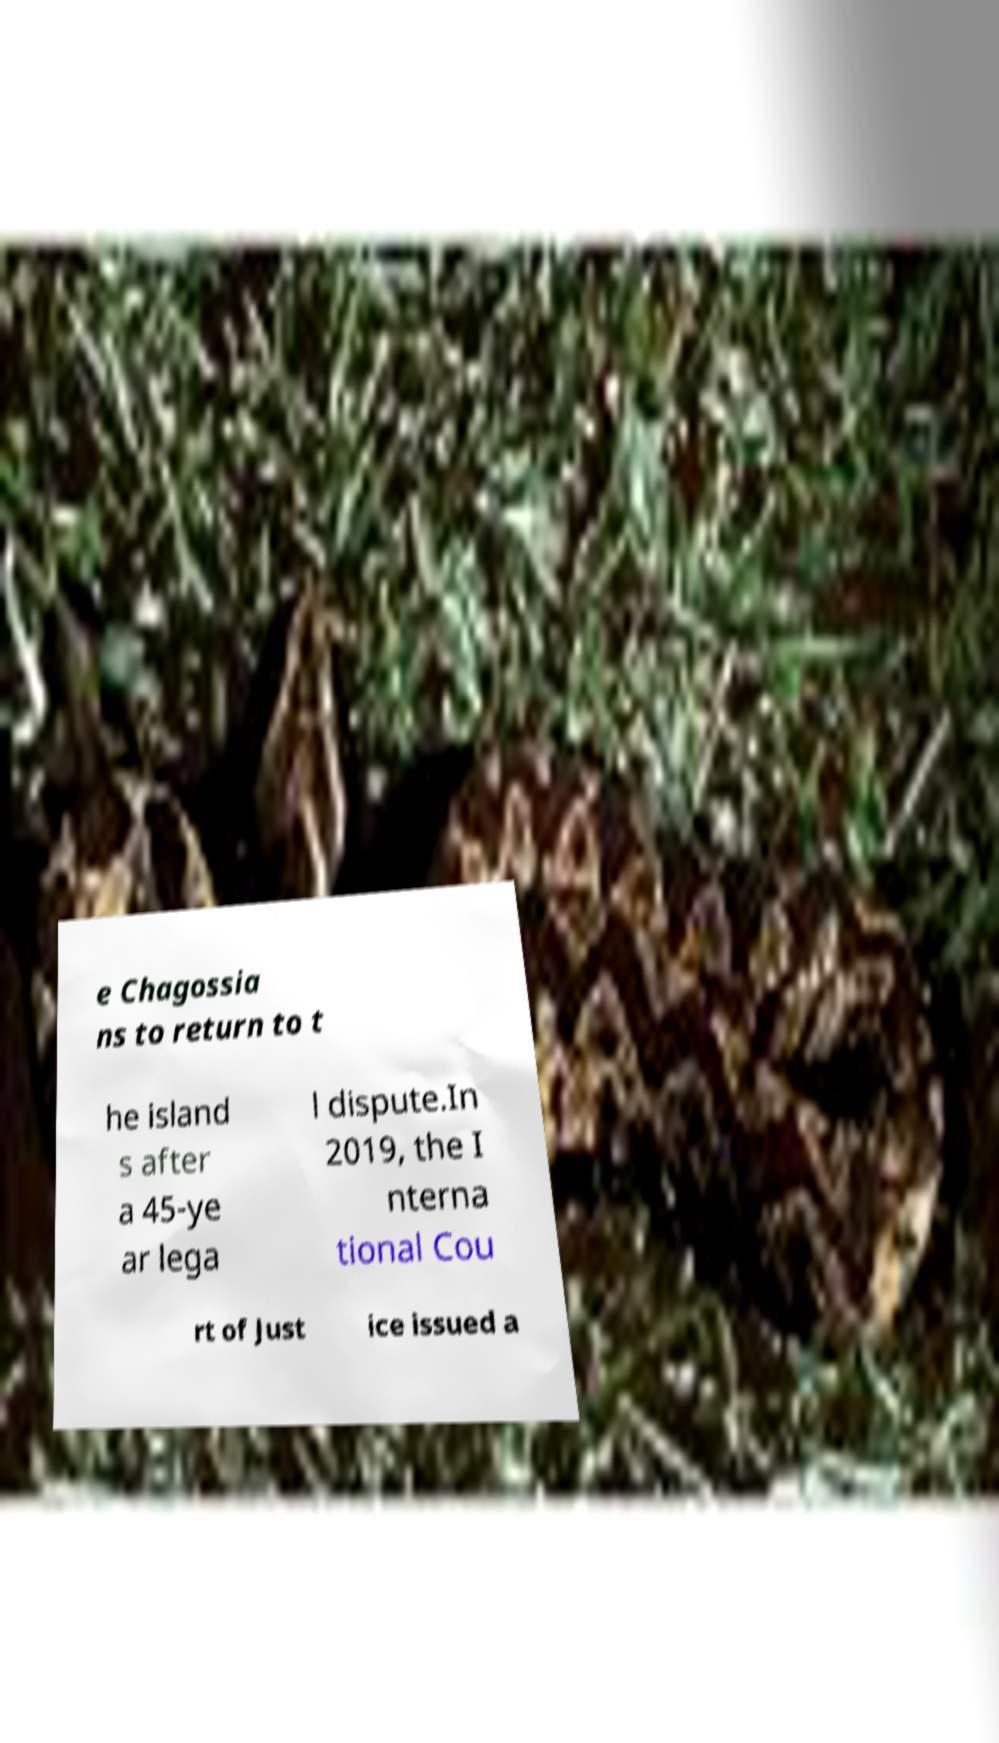Can you accurately transcribe the text from the provided image for me? e Chagossia ns to return to t he island s after a 45-ye ar lega l dispute.In 2019, the I nterna tional Cou rt of Just ice issued a 